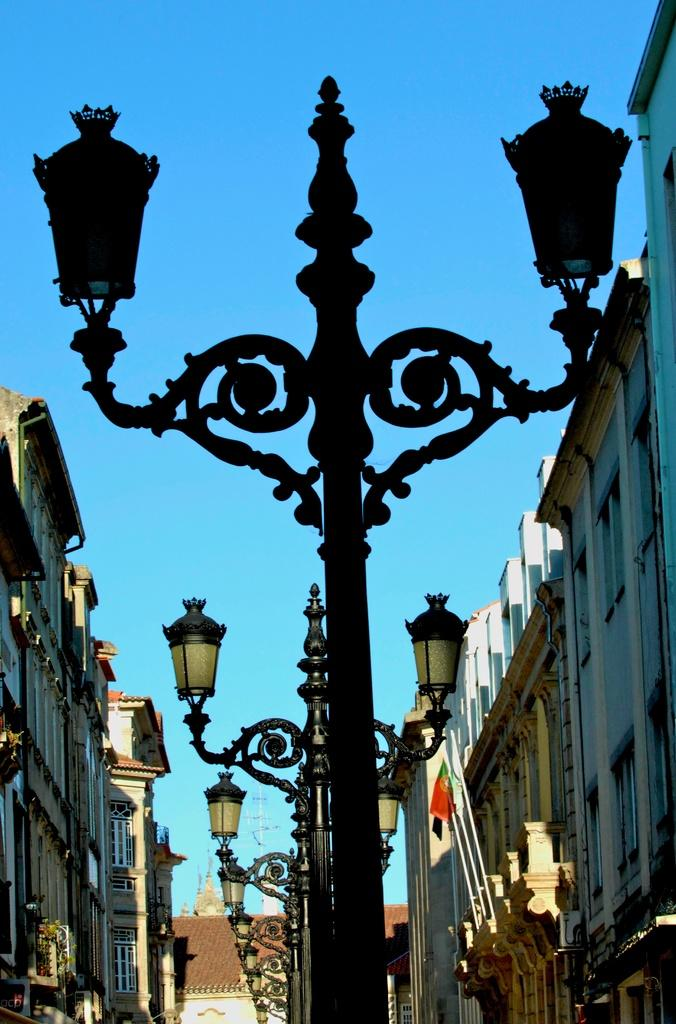What type of structures can be seen in the image? There are street lights, buildings, walls, and windows visible in the image. What other objects can be seen in the image? There are flags and poles in the image. What is visible in the background of the image? The sky is visible in the background of the image. What type of hand can be seen holding the street light in the image? There is no hand holding the street light in the image; it is mounted on a pole. 